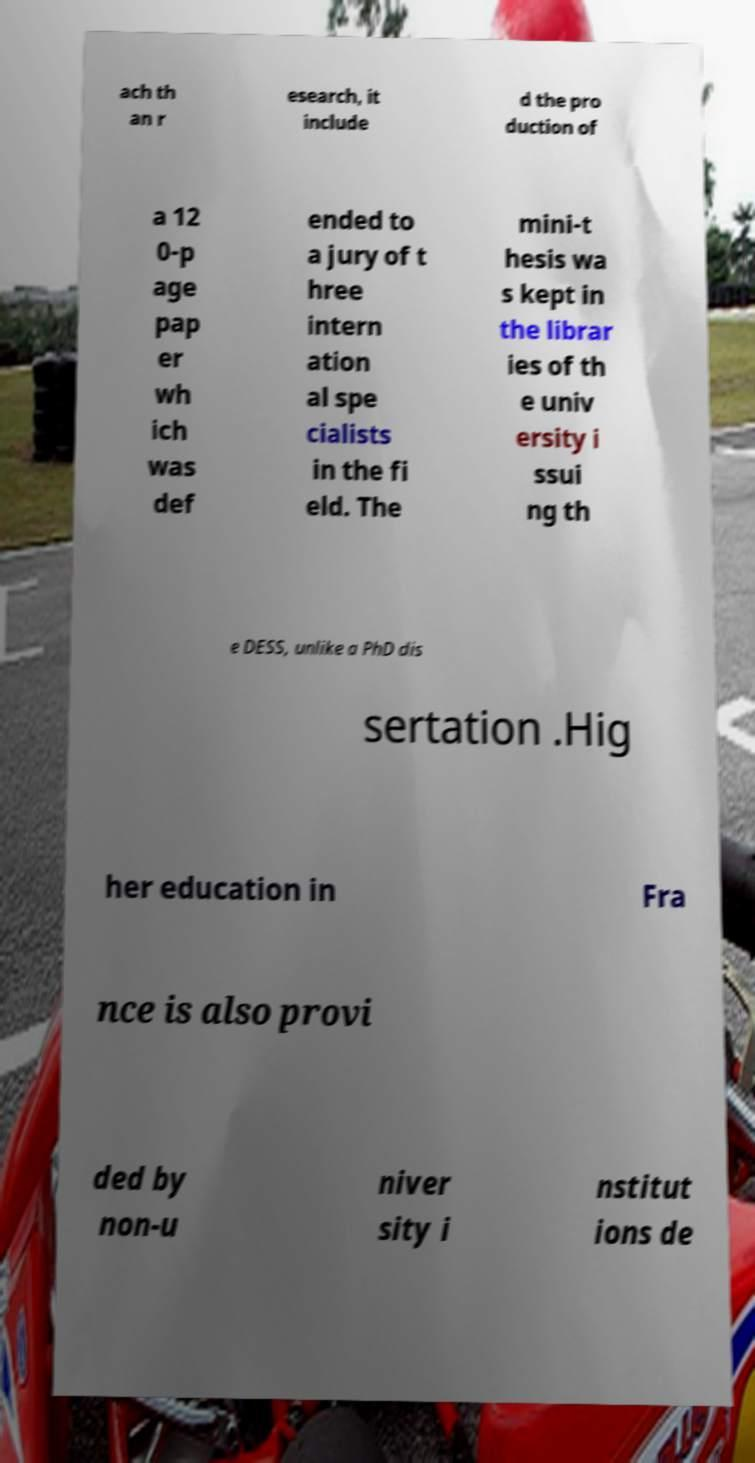I need the written content from this picture converted into text. Can you do that? ach th an r esearch, it include d the pro duction of a 12 0-p age pap er wh ich was def ended to a jury of t hree intern ation al spe cialists in the fi eld. The mini-t hesis wa s kept in the librar ies of th e univ ersity i ssui ng th e DESS, unlike a PhD dis sertation .Hig her education in Fra nce is also provi ded by non-u niver sity i nstitut ions de 